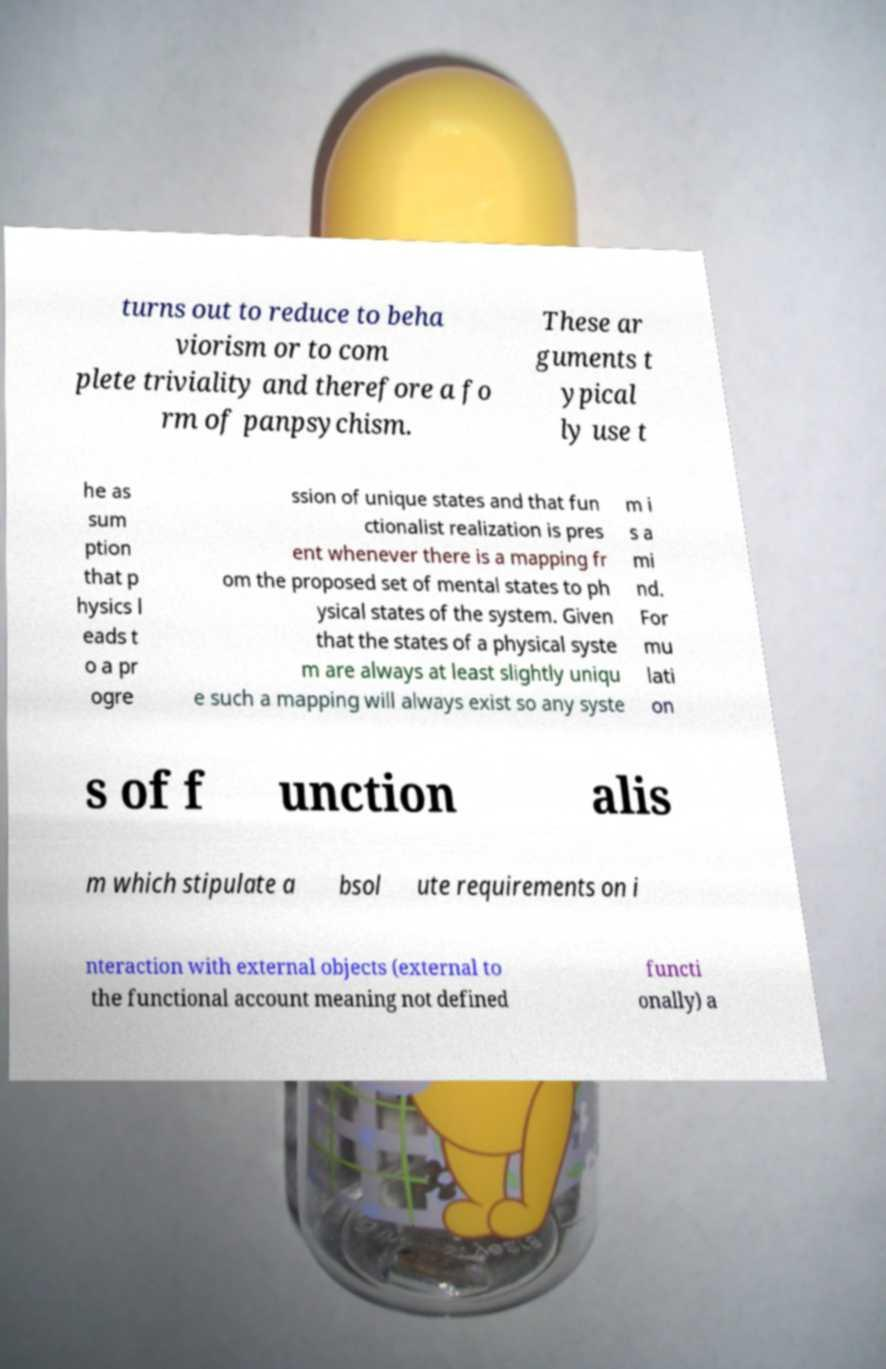Please read and relay the text visible in this image. What does it say? turns out to reduce to beha viorism or to com plete triviality and therefore a fo rm of panpsychism. These ar guments t ypical ly use t he as sum ption that p hysics l eads t o a pr ogre ssion of unique states and that fun ctionalist realization is pres ent whenever there is a mapping fr om the proposed set of mental states to ph ysical states of the system. Given that the states of a physical syste m are always at least slightly uniqu e such a mapping will always exist so any syste m i s a mi nd. For mu lati on s of f unction alis m which stipulate a bsol ute requirements on i nteraction with external objects (external to the functional account meaning not defined functi onally) a 